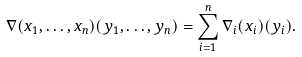<formula> <loc_0><loc_0><loc_500><loc_500>\nabla ( x _ { 1 } , \dots , x _ { n } ) ( y _ { 1 } , \dots , y _ { n } ) = \sum _ { i = 1 } ^ { n } \nabla _ { i } ( x _ { i } ) ( y _ { i } ) .</formula> 